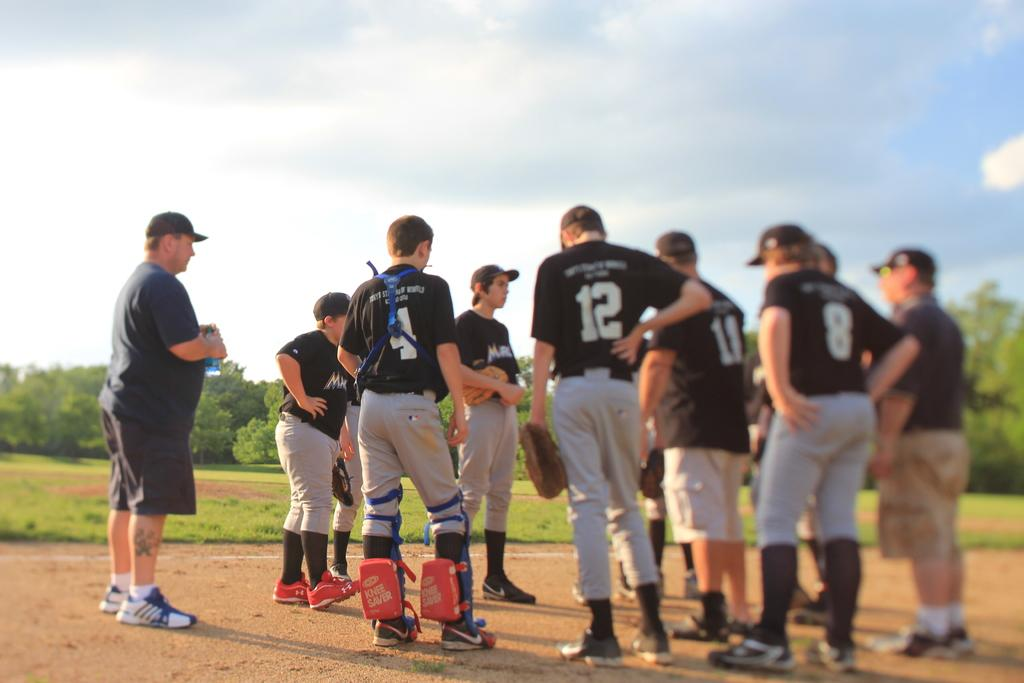<image>
Give a short and clear explanation of the subsequent image. Man wearing number 12 standing in a huddle. 